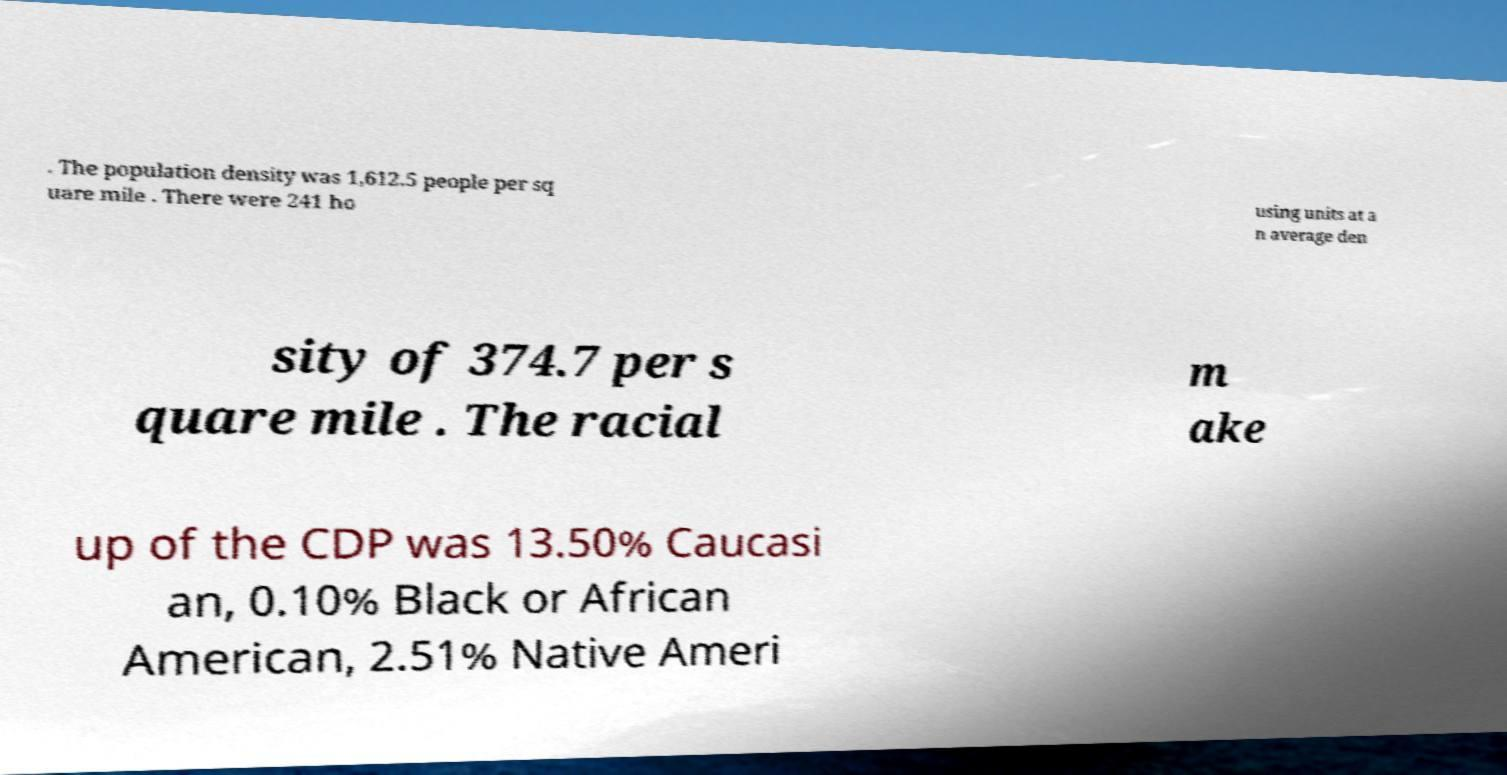There's text embedded in this image that I need extracted. Can you transcribe it verbatim? . The population density was 1,612.5 people per sq uare mile . There were 241 ho using units at a n average den sity of 374.7 per s quare mile . The racial m ake up of the CDP was 13.50% Caucasi an, 0.10% Black or African American, 2.51% Native Ameri 